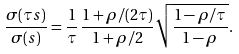<formula> <loc_0><loc_0><loc_500><loc_500>\frac { \sigma ( \tau s ) } { \sigma ( s ) } = \frac { 1 } { \tau } \, \frac { 1 + \rho / ( 2 \tau ) } { 1 + \rho / 2 } \sqrt { \frac { 1 - \rho / \tau } { 1 - \rho } } .</formula> 